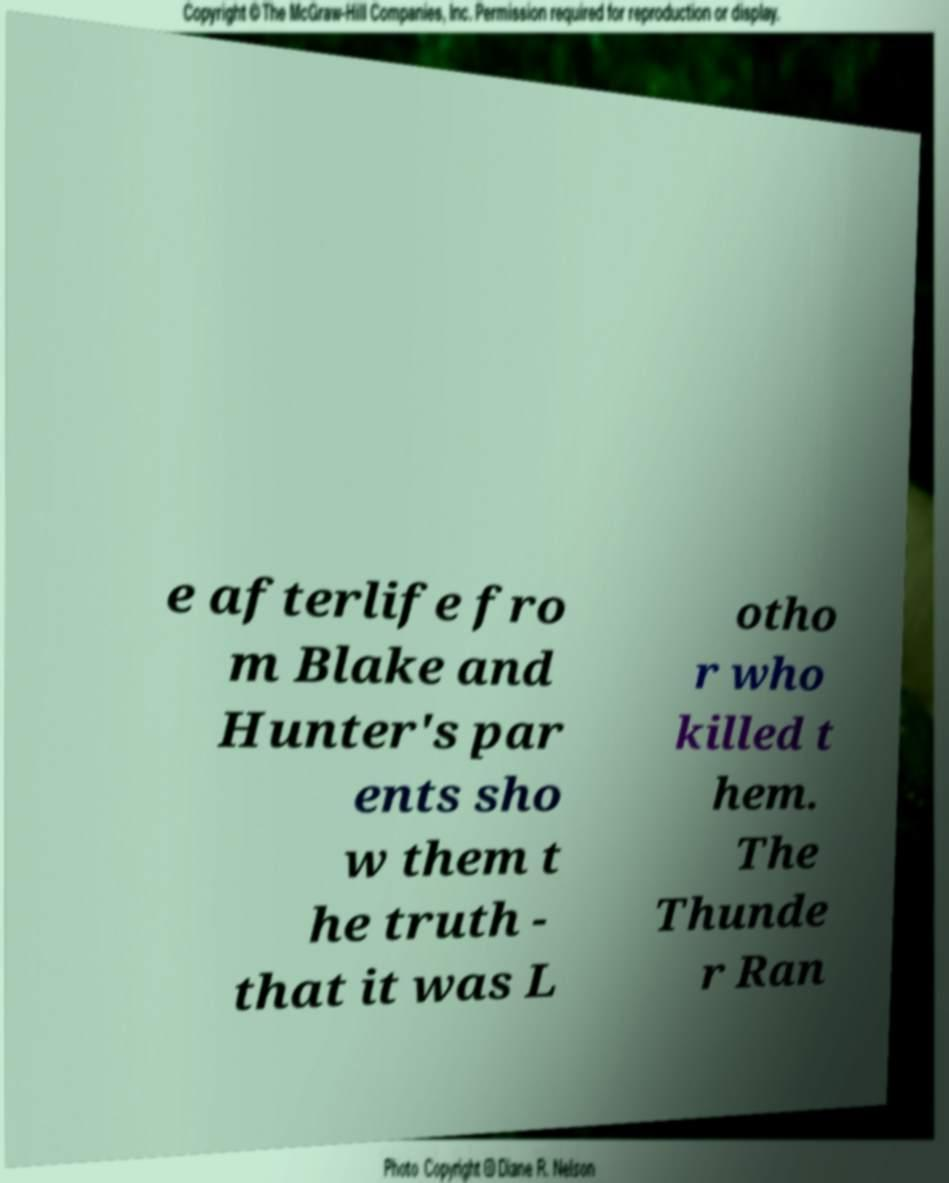I need the written content from this picture converted into text. Can you do that? e afterlife fro m Blake and Hunter's par ents sho w them t he truth - that it was L otho r who killed t hem. The Thunde r Ran 